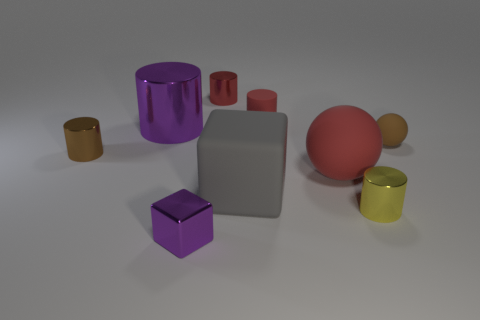How many matte things have the same color as the small block?
Offer a terse response. 0. There is a small yellow object that is the same material as the purple cylinder; what shape is it?
Your answer should be compact. Cylinder. What number of rubber objects are either small blue blocks or big red objects?
Provide a short and direct response. 1. Is the number of yellow objects behind the brown shiny thing the same as the number of gray matte objects?
Offer a very short reply. No. There is a small rubber thing that is right of the large sphere; is it the same color as the big cylinder?
Your answer should be very brief. No. There is a tiny object that is in front of the large red matte object and behind the tiny purple cube; what is its material?
Your response must be concise. Metal. There is a brown object that is to the left of the metal cube; are there any tiny brown rubber spheres that are in front of it?
Your answer should be very brief. No. Is the small ball made of the same material as the purple block?
Your answer should be very brief. No. The object that is both to the right of the big purple object and on the left side of the red metallic object has what shape?
Offer a very short reply. Cube. There is a brown object that is right of the brown cylinder that is behind the gray matte object; what size is it?
Give a very brief answer. Small. 